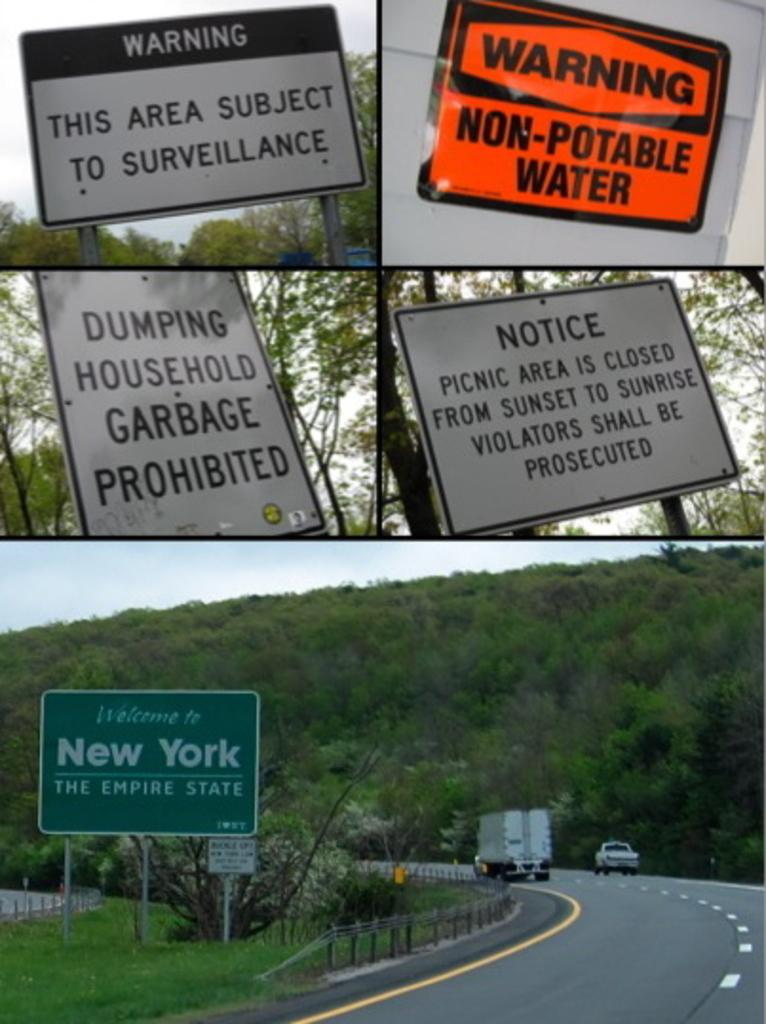What type of image is being described? The image is a collage. What can be seen on the sign boards in the image? The content of the sign boards is not specified, but they are present in the image. What is the purpose of the name board in the image? The purpose of the name board is not specified, but it is present in the image. What type of vehicles are on the road in the image? The specific type of vehicles is not specified, but they are present on the road in the image. What type of vegetation is in the image? There are trees in the image. What type of barrier is in the image? There is a fence in the image. What is visible in the background of the image? The sky is visible in the background of the image. How do the toys in the image help with digestion? There are no toys present in the image, and therefore no such activity can be observed. 